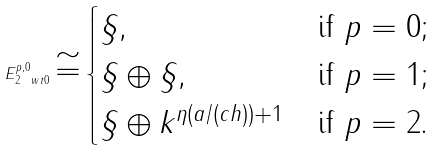<formula> <loc_0><loc_0><loc_500><loc_500>E _ { 2 \ w t 0 } ^ { p , 0 } \cong \begin{cases} \S , & \text {if $p=0$;} \\ \S \oplus \S , & \text {if $p=1$;} \\ \S \oplus k ^ { \eta ( a / ( c h ) ) + 1 } & \text {if $p=2$.} \end{cases}</formula> 